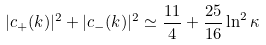Convert formula to latex. <formula><loc_0><loc_0><loc_500><loc_500>| c _ { + } ( k ) | ^ { 2 } + | c _ { - } ( k ) | ^ { 2 } \simeq \frac { 1 1 } { 4 } + \frac { 2 5 } { 1 6 } \ln ^ { 2 } { \kappa }</formula> 